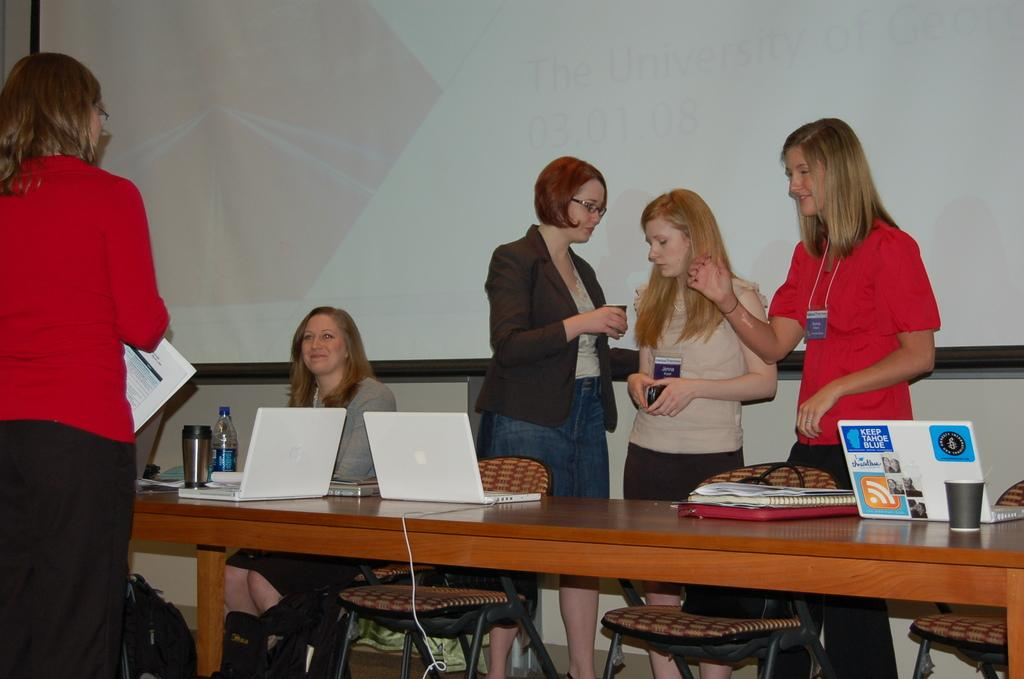What is the main object in the image? There is a screen in the image. Who or what is in front of the screen? There are people in the image. What is the people interacting with in the image? There is a table in the image with laptops, books, and a glass on it. What type of electronic devices are on the table? There are laptops on the table. What type of coil is being used to frame the screen in the image? There is no coil or framing device visible in the image; it only shows a screen, people, and a table with laptops, books, and a glass. 